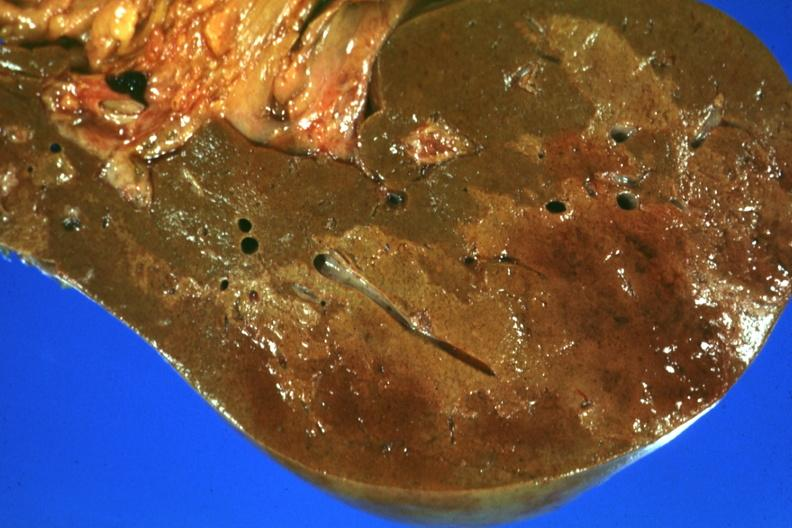s mixed mesodermal tumor present?
Answer the question using a single word or phrase. No 